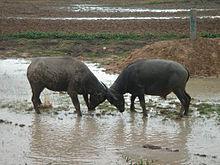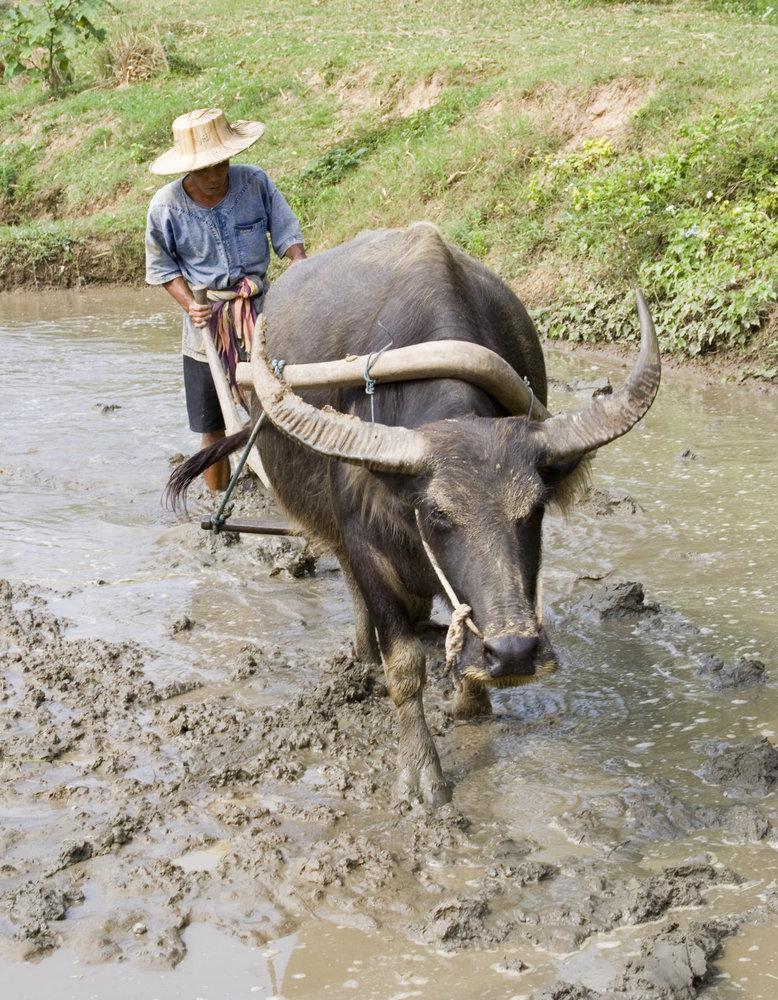The first image is the image on the left, the second image is the image on the right. For the images shown, is this caption "There is water in the image on the left." true? Answer yes or no. Yes. 